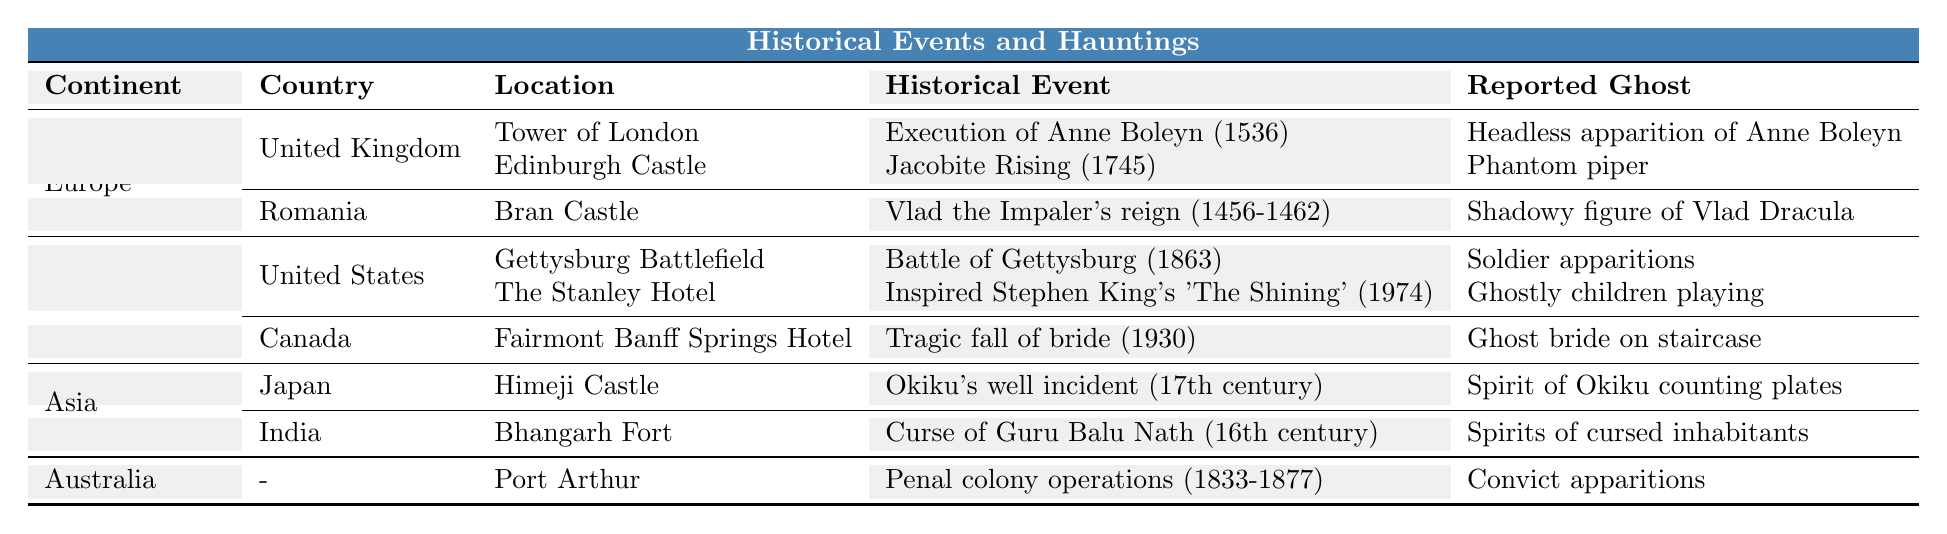What historical event is associated with the Tower of London? The table specifies that the historical event associated with the Tower of London is the Execution of Anne Boleyn in 1536.
Answer: Execution of Anne Boleyn Which ghost is reported at the Gettysburg Battlefield? According to the table, the ghost reported at the Gettysburg Battlefield is Soldier apparitions.
Answer: Soldier apparitions In what year did the Jacobite Rising occur at Edinburgh Castle? The table indicates that the Jacobite Rising occurred in 1745 at Edinburgh Castle.
Answer: 1745 How many reported ghosts are mentioned for haunted locations in North America? Two locations in North America are mentioned with reported ghosts: the Gettysburg Battlefield and The Stanley Hotel, leading to a total of two reported ghosts.
Answer: 2 Is the reported ghost at Bran Castle a historical figure? Yes, the reported ghost at Bran Castle is described as a shadowy figure of Vlad Dracula, a historical figure.
Answer: Yes What is the historical event associated with the Fairmont Banff Springs Hotel? The table states that the historical event associated with the Fairmont Banff Springs Hotel is the Tragic fall of bride in 1930.
Answer: Tragic fall of bride Which continent has the highest number of haunted locations in the table? By reviewing the table, Europe and North America both have two haunted locations, while Asia has two as well. Therefore, no single continent has more than the others listed.
Answer: None Which reported ghost is mentioned for the Port Arthur site in Australia? The Port Arthur site in Australia is associated with the reported ghost of convict apparitions.
Answer: Convict apparitions How many historical events are associated with haunted locations in Asia? The table shows that there are two haunted locations in Asia, each associated with one historical event: Himeji Castle and Bhangarh Fort, resulting in two historical events.
Answer: 2 Which ghost is associated with Anne Boleyn at the Tower of London? According to the table, the ghost associated with Anne Boleyn at the Tower of London is a headless apparition of Anne Boleyn.
Answer: Headless apparition of Anne Boleyn 